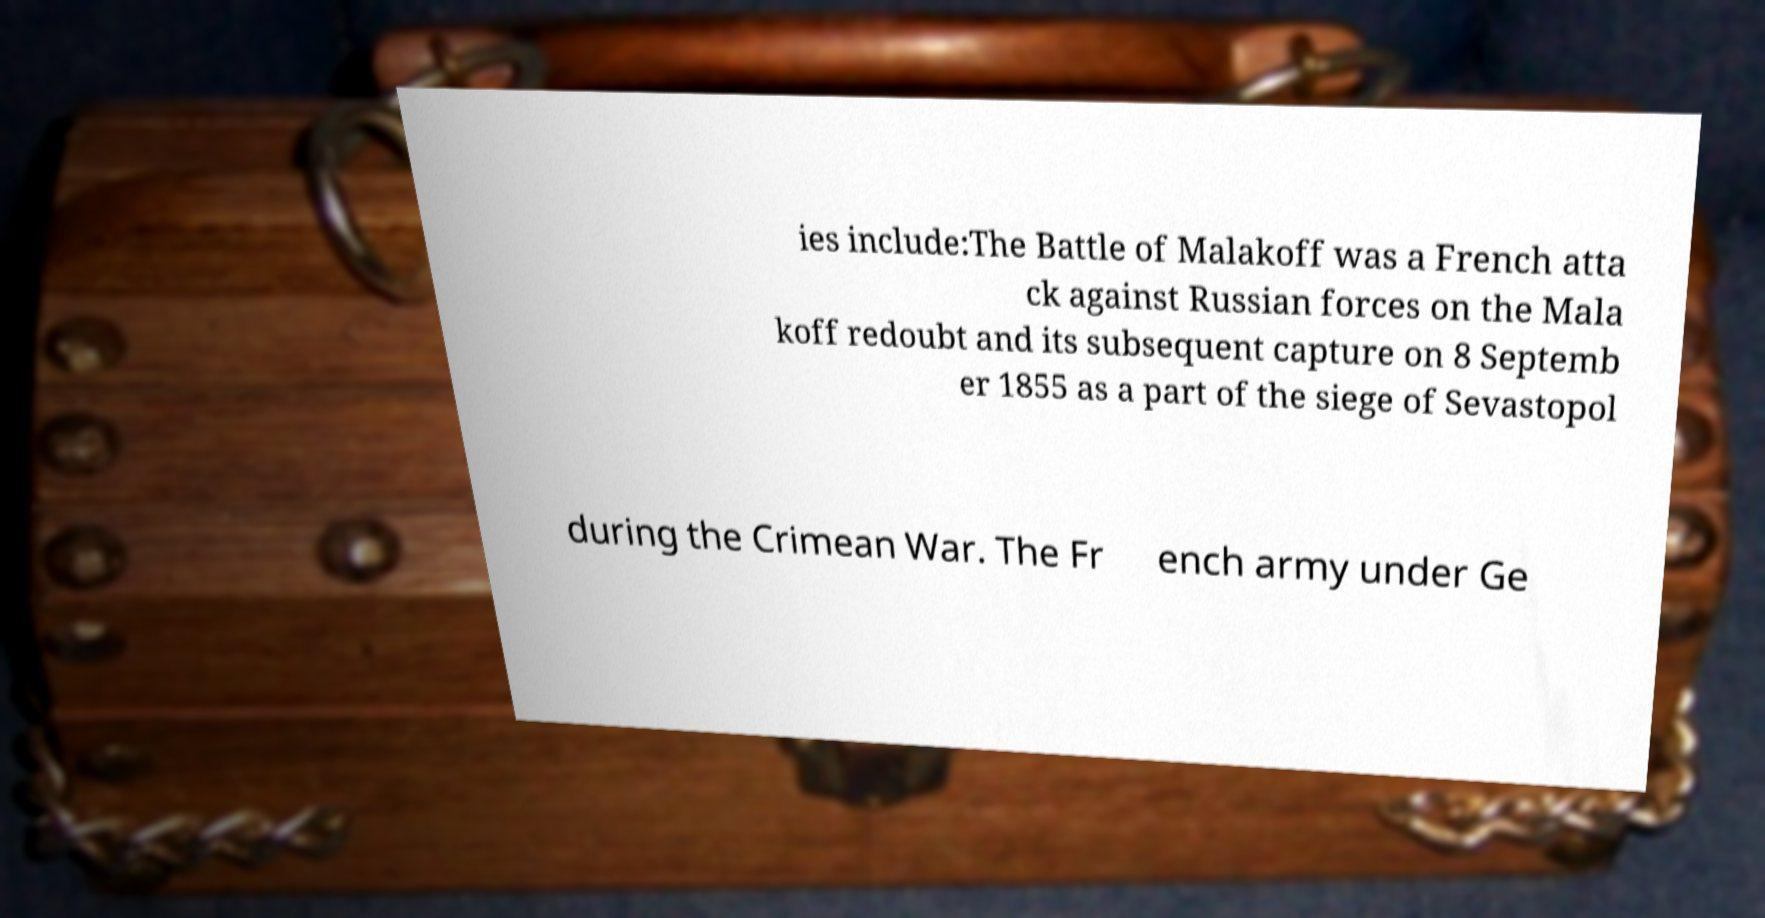I need the written content from this picture converted into text. Can you do that? ies include:The Battle of Malakoff was a French atta ck against Russian forces on the Mala koff redoubt and its subsequent capture on 8 Septemb er 1855 as a part of the siege of Sevastopol during the Crimean War. The Fr ench army under Ge 